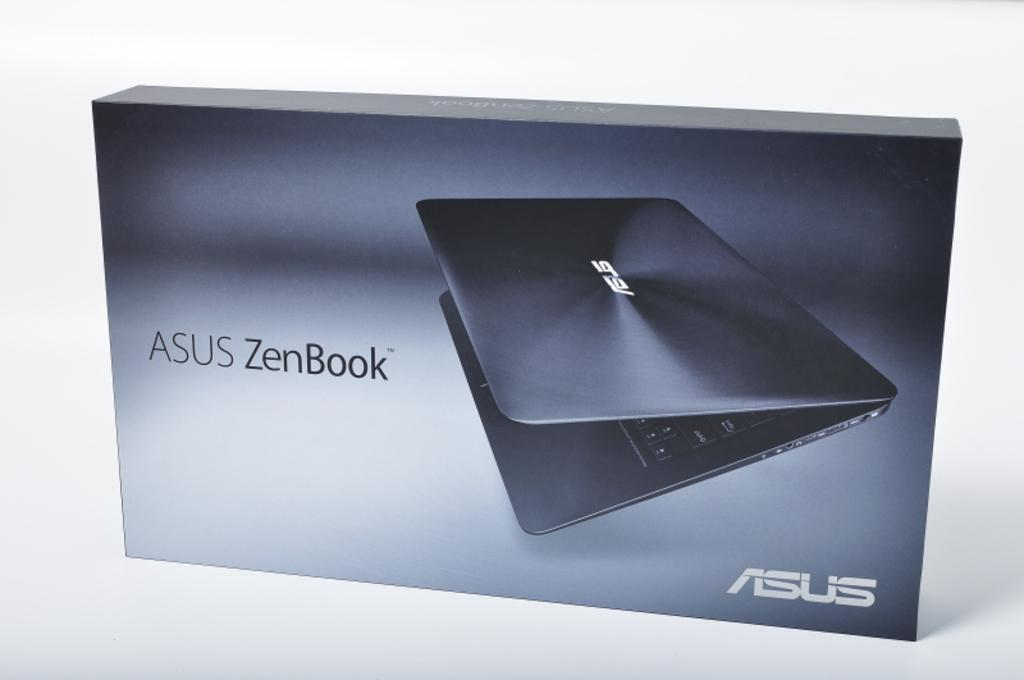<image>
Create a compact narrative representing the image presented. An Asus ZenBook is shown on the cover of a box. 